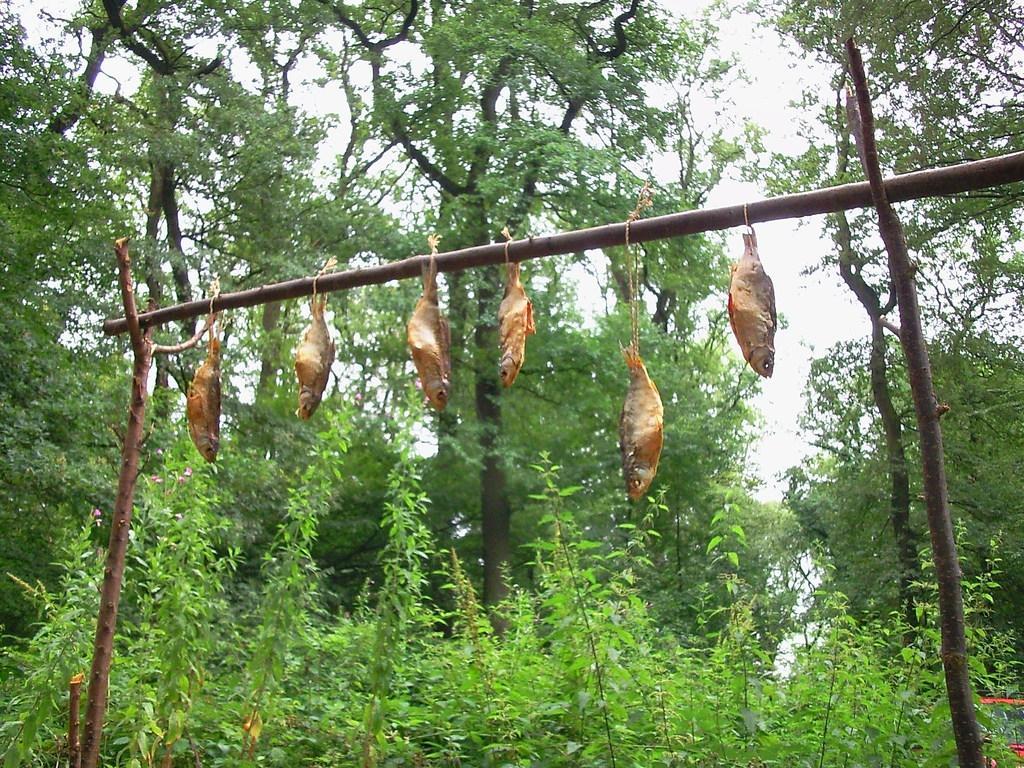Please provide a concise description of this image. In this picture there are fishes hanging on the stick. At the back there are trees. At the top there is sky. At the bottom there are plants. 